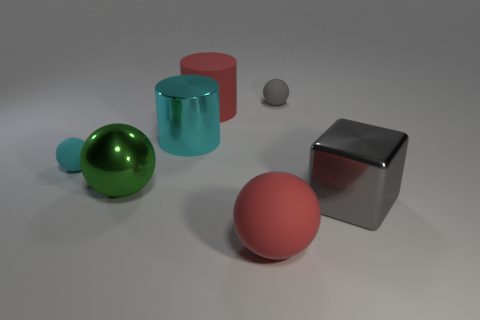How many green metal objects are the same size as the gray block?
Your response must be concise. 1. Do the red sphere and the cyan metal cylinder have the same size?
Offer a very short reply. Yes. There is a matte thing that is both in front of the matte cylinder and left of the red ball; what is its size?
Your answer should be compact. Small. Is the number of large red matte cylinders that are in front of the cyan rubber thing greater than the number of big red matte objects that are to the left of the cyan cylinder?
Provide a short and direct response. No. The other tiny matte thing that is the same shape as the tiny gray matte object is what color?
Provide a short and direct response. Cyan. Do the big ball to the right of the large shiny cylinder and the big block have the same color?
Offer a very short reply. No. What number of small cyan cylinders are there?
Offer a terse response. 0. Does the small sphere that is on the left side of the red cylinder have the same material as the big red cylinder?
Your answer should be compact. Yes. Is there any other thing that has the same material as the large green sphere?
Ensure brevity in your answer.  Yes. How many green shiny balls are behind the small rubber thing behind the tiny sphere that is left of the large red matte sphere?
Ensure brevity in your answer.  0. 